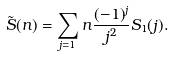<formula> <loc_0><loc_0><loc_500><loc_500>\tilde { S } ( n ) = \sum _ { j = 1 } { n } \frac { ( - 1 ) ^ { j } } { j ^ { 2 } } S _ { 1 } ( j ) .</formula> 